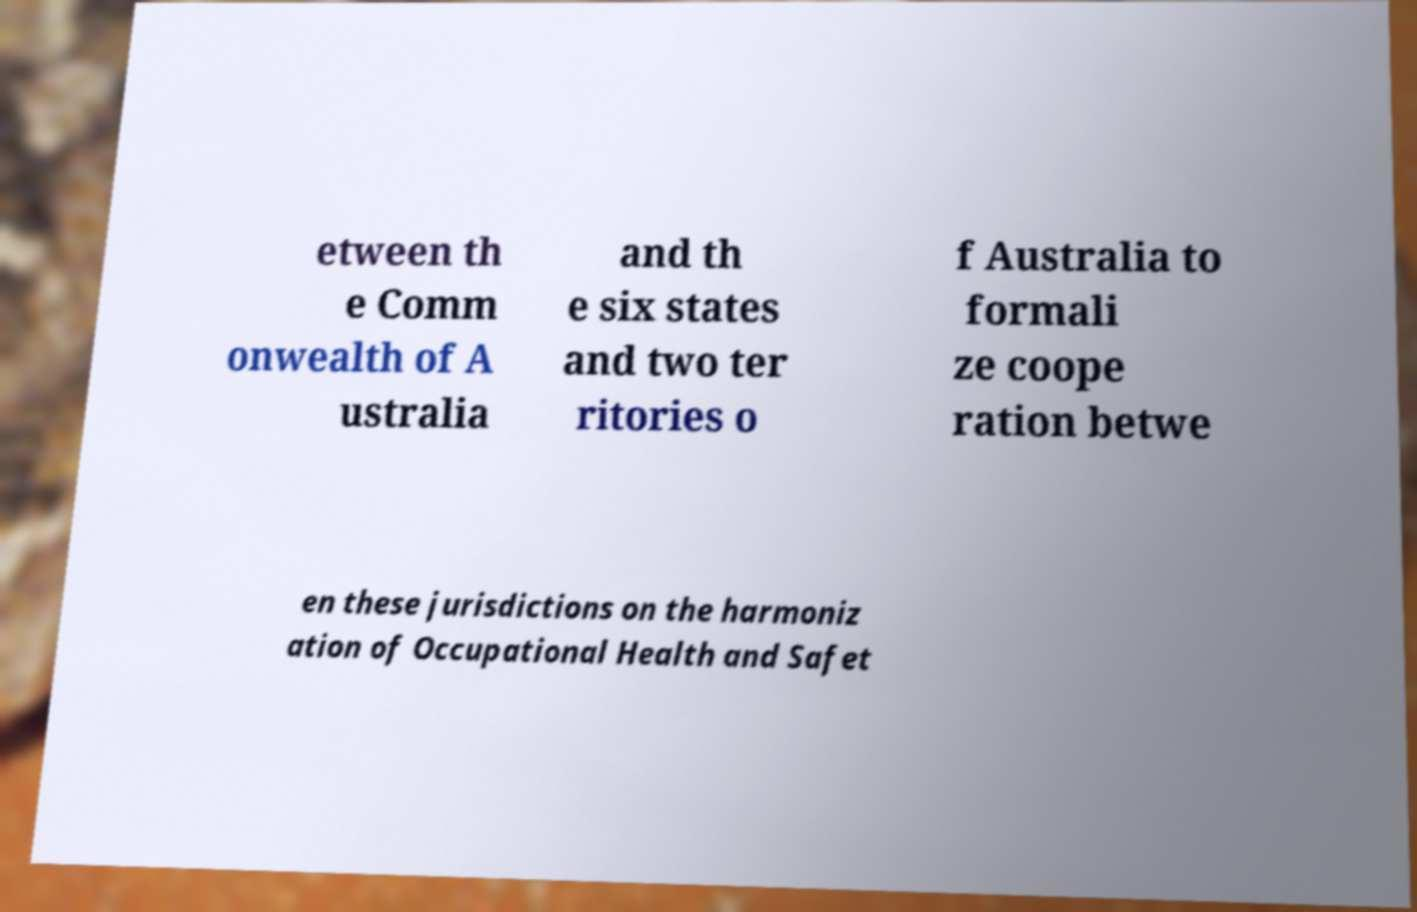Could you extract and type out the text from this image? etween th e Comm onwealth of A ustralia and th e six states and two ter ritories o f Australia to formali ze coope ration betwe en these jurisdictions on the harmoniz ation of Occupational Health and Safet 